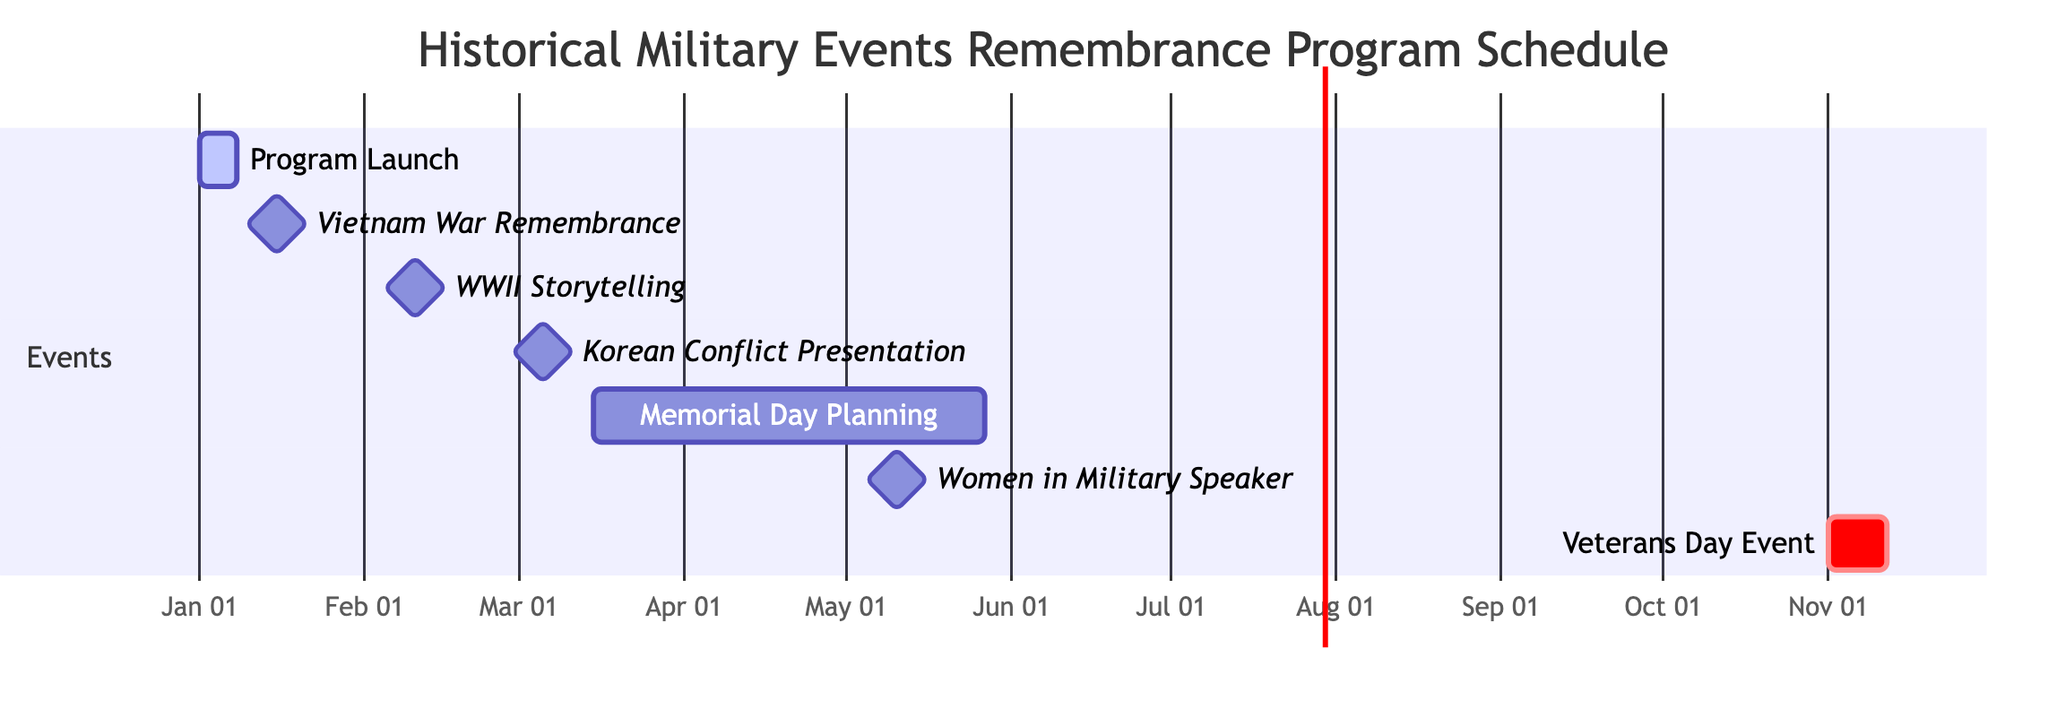What is the start date of the Program Launch? The Gantt Chart indicates that the Program Launch task begins on January 1, 2024. You can find this information by locating the "Program Launch" task and observing the start date listed next to it.
Answer: January 1, 2024 How long is the duration of the Memorial Day Ceremony Planning? The Memorial Day Ceremony Planning task has a duration listed as 74 days. This is obtained by looking at the task title and finding the associated duration information.
Answer: 74 days What is the end date of the Vietnam War Remembrance Day Event? The Gantt Chart shows that the Vietnam War Remembrance Day Event occurs on January 15, 2024. This is found under the task title for the event, where both the start and end date are the same.
Answer: January 15, 2024 How many days are scheduled between the Program Launch and the Vietnam War Remembrance Day Event? To calculate the days between January 1, 2024 (the end of the Program Launch) and January 15, 2024 (the start of the Vietnam War Remembrance Day Event), you identify the end date of the Program Launch is January 7, 2024, and then count the days until January 15, resulting in 8 days.
Answer: 8 days Which event occurs directly after the Korean Conflict Historical Presentation? The Korean Conflict Historical Presentation is scheduled on March 5, 2024. The next event is the Memorial Day Ceremony Planning, which starts on March 15, 2024. By checking the timeline, you see that the Memorial Day Ceremony Planning follows.
Answer: Memorial Day Ceremony Planning What tasks are categorized as milestones in the schedule? The tasks designated as milestones are Vietnam War Remembrance Day Event, WWII Storytelling Session, Korean Conflict Historical Presentation, and Women in Military Speaker. You can identify these tasks by checking the diagram for the “milestone” label next to these events.
Answer: Vietnam War Remembrance Day Event, WWII Storytelling Session, Korean Conflict Historical Presentation, Women in Military Speaker What is the latest task in the schedule? The latest task in the schedule is the Veterans Day Remembrance Event, which begins on November 1, 2024, and lasts for 11 days. By scanning through the tasks, this event appears at the end of the timeline.
Answer: Veterans Day Remembrance Event How many tasks are scheduled between the Memorial Day Ceremony Planning and the Veterans Day Remembrance Event? There are three tasks scheduled between Memorial Day Ceremony Planning and Veterans Day Remembrance Event: Guest Speaker Series: Women in the Military, WWII Storytelling Session, and Korean Conflict Historical Presentation. Counting these tasks yields a total of 3.
Answer: 3 tasks 